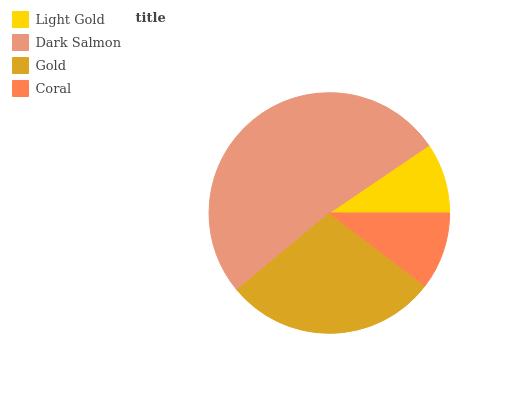Is Light Gold the minimum?
Answer yes or no. Yes. Is Dark Salmon the maximum?
Answer yes or no. Yes. Is Gold the minimum?
Answer yes or no. No. Is Gold the maximum?
Answer yes or no. No. Is Dark Salmon greater than Gold?
Answer yes or no. Yes. Is Gold less than Dark Salmon?
Answer yes or no. Yes. Is Gold greater than Dark Salmon?
Answer yes or no. No. Is Dark Salmon less than Gold?
Answer yes or no. No. Is Gold the high median?
Answer yes or no. Yes. Is Coral the low median?
Answer yes or no. Yes. Is Coral the high median?
Answer yes or no. No. Is Gold the low median?
Answer yes or no. No. 